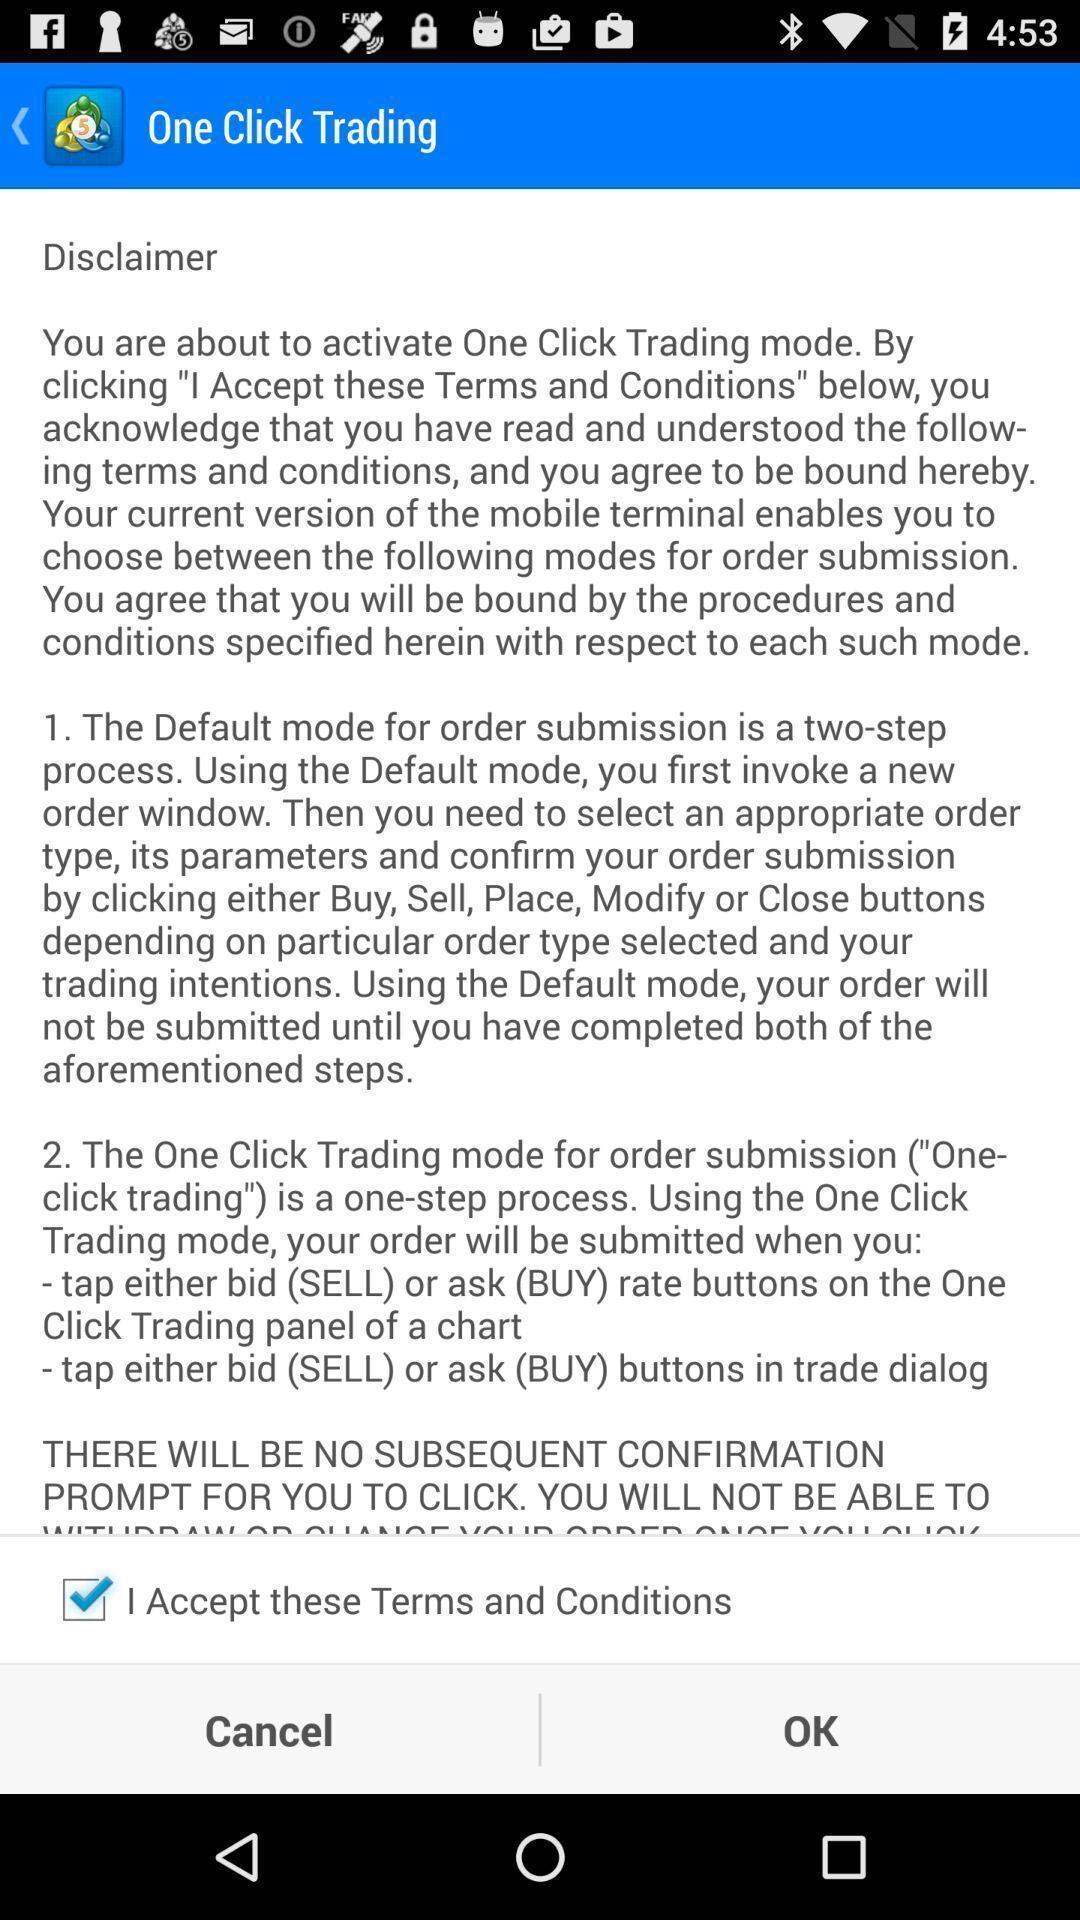Describe the visual elements of this screenshot. Page displaying terms and conditions. 